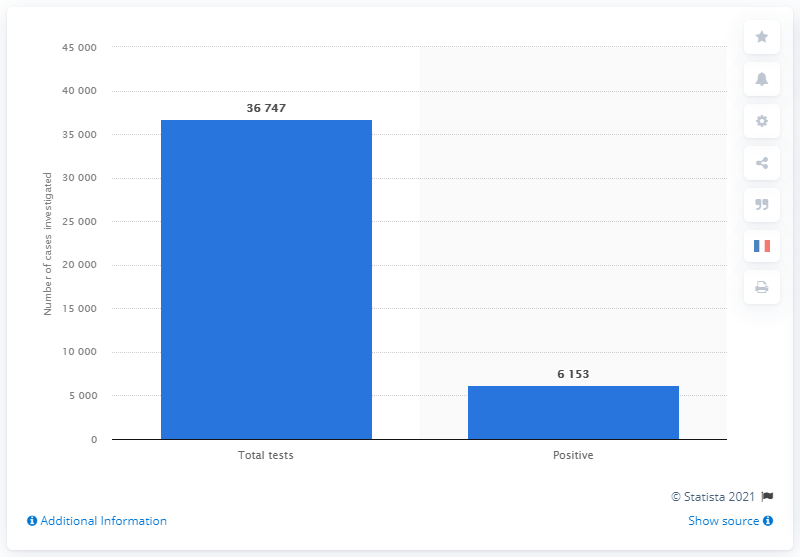Give some essential details in this illustration. The value of the lowest bar is 6153 What is the distinction between the two bars? The number is 30594... 